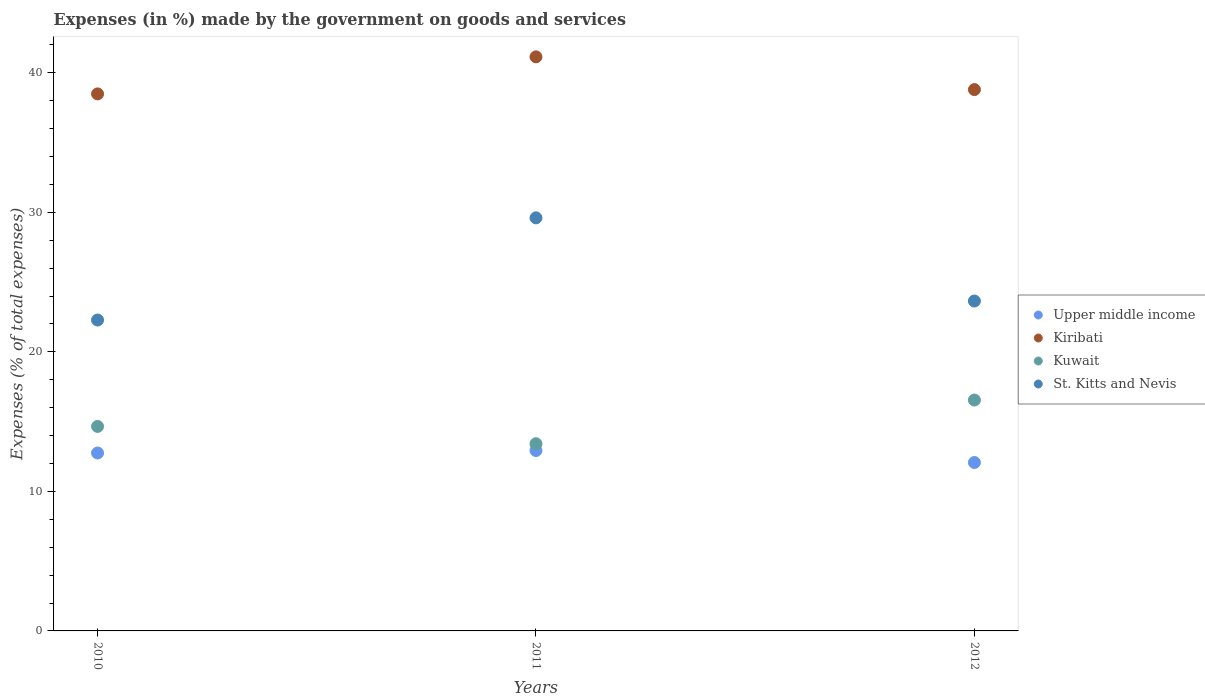How many different coloured dotlines are there?
Provide a short and direct response. 4. What is the percentage of expenses made by the government on goods and services in Kuwait in 2012?
Offer a very short reply. 16.55. Across all years, what is the maximum percentage of expenses made by the government on goods and services in Kuwait?
Offer a terse response. 16.55. Across all years, what is the minimum percentage of expenses made by the government on goods and services in Kuwait?
Make the answer very short. 13.41. In which year was the percentage of expenses made by the government on goods and services in Kuwait minimum?
Offer a very short reply. 2011. What is the total percentage of expenses made by the government on goods and services in Upper middle income in the graph?
Give a very brief answer. 37.75. What is the difference between the percentage of expenses made by the government on goods and services in Kiribati in 2011 and that in 2012?
Make the answer very short. 2.35. What is the difference between the percentage of expenses made by the government on goods and services in Upper middle income in 2011 and the percentage of expenses made by the government on goods and services in Kuwait in 2010?
Make the answer very short. -1.73. What is the average percentage of expenses made by the government on goods and services in Kuwait per year?
Give a very brief answer. 14.87. In the year 2012, what is the difference between the percentage of expenses made by the government on goods and services in Kiribati and percentage of expenses made by the government on goods and services in Upper middle income?
Offer a terse response. 26.72. What is the ratio of the percentage of expenses made by the government on goods and services in St. Kitts and Nevis in 2011 to that in 2012?
Your response must be concise. 1.25. What is the difference between the highest and the second highest percentage of expenses made by the government on goods and services in Kuwait?
Ensure brevity in your answer.  1.89. What is the difference between the highest and the lowest percentage of expenses made by the government on goods and services in Kiribati?
Your answer should be compact. 2.65. Is the sum of the percentage of expenses made by the government on goods and services in Kiribati in 2010 and 2011 greater than the maximum percentage of expenses made by the government on goods and services in St. Kitts and Nevis across all years?
Ensure brevity in your answer.  Yes. Is the percentage of expenses made by the government on goods and services in St. Kitts and Nevis strictly greater than the percentage of expenses made by the government on goods and services in Kiribati over the years?
Provide a succinct answer. No. How many dotlines are there?
Give a very brief answer. 4. How many years are there in the graph?
Your response must be concise. 3. What is the difference between two consecutive major ticks on the Y-axis?
Offer a terse response. 10. Are the values on the major ticks of Y-axis written in scientific E-notation?
Your response must be concise. No. Does the graph contain any zero values?
Your answer should be very brief. No. Where does the legend appear in the graph?
Provide a short and direct response. Center right. How many legend labels are there?
Your answer should be compact. 4. How are the legend labels stacked?
Give a very brief answer. Vertical. What is the title of the graph?
Your answer should be compact. Expenses (in %) made by the government on goods and services. What is the label or title of the X-axis?
Provide a succinct answer. Years. What is the label or title of the Y-axis?
Your answer should be very brief. Expenses (% of total expenses). What is the Expenses (% of total expenses) in Upper middle income in 2010?
Offer a terse response. 12.75. What is the Expenses (% of total expenses) in Kiribati in 2010?
Keep it short and to the point. 38.49. What is the Expenses (% of total expenses) of Kuwait in 2010?
Ensure brevity in your answer.  14.65. What is the Expenses (% of total expenses) in St. Kitts and Nevis in 2010?
Your answer should be compact. 22.28. What is the Expenses (% of total expenses) of Upper middle income in 2011?
Offer a terse response. 12.93. What is the Expenses (% of total expenses) of Kiribati in 2011?
Give a very brief answer. 41.14. What is the Expenses (% of total expenses) of Kuwait in 2011?
Keep it short and to the point. 13.41. What is the Expenses (% of total expenses) in St. Kitts and Nevis in 2011?
Your response must be concise. 29.6. What is the Expenses (% of total expenses) of Upper middle income in 2012?
Ensure brevity in your answer.  12.07. What is the Expenses (% of total expenses) of Kiribati in 2012?
Provide a succinct answer. 38.79. What is the Expenses (% of total expenses) in Kuwait in 2012?
Provide a short and direct response. 16.55. What is the Expenses (% of total expenses) of St. Kitts and Nevis in 2012?
Your answer should be compact. 23.64. Across all years, what is the maximum Expenses (% of total expenses) in Upper middle income?
Your answer should be very brief. 12.93. Across all years, what is the maximum Expenses (% of total expenses) in Kiribati?
Keep it short and to the point. 41.14. Across all years, what is the maximum Expenses (% of total expenses) of Kuwait?
Provide a short and direct response. 16.55. Across all years, what is the maximum Expenses (% of total expenses) of St. Kitts and Nevis?
Offer a very short reply. 29.6. Across all years, what is the minimum Expenses (% of total expenses) in Upper middle income?
Offer a very short reply. 12.07. Across all years, what is the minimum Expenses (% of total expenses) of Kiribati?
Offer a terse response. 38.49. Across all years, what is the minimum Expenses (% of total expenses) of Kuwait?
Your answer should be very brief. 13.41. Across all years, what is the minimum Expenses (% of total expenses) in St. Kitts and Nevis?
Provide a short and direct response. 22.28. What is the total Expenses (% of total expenses) of Upper middle income in the graph?
Provide a short and direct response. 37.75. What is the total Expenses (% of total expenses) in Kiribati in the graph?
Your answer should be compact. 118.42. What is the total Expenses (% of total expenses) of Kuwait in the graph?
Your answer should be compact. 44.61. What is the total Expenses (% of total expenses) in St. Kitts and Nevis in the graph?
Provide a succinct answer. 75.52. What is the difference between the Expenses (% of total expenses) of Upper middle income in 2010 and that in 2011?
Your answer should be compact. -0.18. What is the difference between the Expenses (% of total expenses) of Kiribati in 2010 and that in 2011?
Your response must be concise. -2.65. What is the difference between the Expenses (% of total expenses) in Kuwait in 2010 and that in 2011?
Your response must be concise. 1.24. What is the difference between the Expenses (% of total expenses) of St. Kitts and Nevis in 2010 and that in 2011?
Provide a succinct answer. -7.32. What is the difference between the Expenses (% of total expenses) in Upper middle income in 2010 and that in 2012?
Your answer should be very brief. 0.68. What is the difference between the Expenses (% of total expenses) of Kiribati in 2010 and that in 2012?
Your response must be concise. -0.31. What is the difference between the Expenses (% of total expenses) of Kuwait in 2010 and that in 2012?
Offer a very short reply. -1.89. What is the difference between the Expenses (% of total expenses) in St. Kitts and Nevis in 2010 and that in 2012?
Provide a succinct answer. -1.36. What is the difference between the Expenses (% of total expenses) of Upper middle income in 2011 and that in 2012?
Make the answer very short. 0.86. What is the difference between the Expenses (% of total expenses) of Kiribati in 2011 and that in 2012?
Ensure brevity in your answer.  2.35. What is the difference between the Expenses (% of total expenses) in Kuwait in 2011 and that in 2012?
Keep it short and to the point. -3.13. What is the difference between the Expenses (% of total expenses) of St. Kitts and Nevis in 2011 and that in 2012?
Your answer should be compact. 5.96. What is the difference between the Expenses (% of total expenses) in Upper middle income in 2010 and the Expenses (% of total expenses) in Kiribati in 2011?
Offer a very short reply. -28.39. What is the difference between the Expenses (% of total expenses) in Upper middle income in 2010 and the Expenses (% of total expenses) in Kuwait in 2011?
Ensure brevity in your answer.  -0.66. What is the difference between the Expenses (% of total expenses) of Upper middle income in 2010 and the Expenses (% of total expenses) of St. Kitts and Nevis in 2011?
Keep it short and to the point. -16.85. What is the difference between the Expenses (% of total expenses) in Kiribati in 2010 and the Expenses (% of total expenses) in Kuwait in 2011?
Offer a terse response. 25.07. What is the difference between the Expenses (% of total expenses) of Kiribati in 2010 and the Expenses (% of total expenses) of St. Kitts and Nevis in 2011?
Your answer should be very brief. 8.88. What is the difference between the Expenses (% of total expenses) of Kuwait in 2010 and the Expenses (% of total expenses) of St. Kitts and Nevis in 2011?
Give a very brief answer. -14.95. What is the difference between the Expenses (% of total expenses) in Upper middle income in 2010 and the Expenses (% of total expenses) in Kiribati in 2012?
Offer a terse response. -26.04. What is the difference between the Expenses (% of total expenses) in Upper middle income in 2010 and the Expenses (% of total expenses) in Kuwait in 2012?
Give a very brief answer. -3.79. What is the difference between the Expenses (% of total expenses) in Upper middle income in 2010 and the Expenses (% of total expenses) in St. Kitts and Nevis in 2012?
Make the answer very short. -10.89. What is the difference between the Expenses (% of total expenses) in Kiribati in 2010 and the Expenses (% of total expenses) in Kuwait in 2012?
Your response must be concise. 21.94. What is the difference between the Expenses (% of total expenses) in Kiribati in 2010 and the Expenses (% of total expenses) in St. Kitts and Nevis in 2012?
Your answer should be compact. 14.84. What is the difference between the Expenses (% of total expenses) of Kuwait in 2010 and the Expenses (% of total expenses) of St. Kitts and Nevis in 2012?
Provide a succinct answer. -8.99. What is the difference between the Expenses (% of total expenses) in Upper middle income in 2011 and the Expenses (% of total expenses) in Kiribati in 2012?
Provide a short and direct response. -25.86. What is the difference between the Expenses (% of total expenses) of Upper middle income in 2011 and the Expenses (% of total expenses) of Kuwait in 2012?
Provide a short and direct response. -3.62. What is the difference between the Expenses (% of total expenses) of Upper middle income in 2011 and the Expenses (% of total expenses) of St. Kitts and Nevis in 2012?
Ensure brevity in your answer.  -10.71. What is the difference between the Expenses (% of total expenses) of Kiribati in 2011 and the Expenses (% of total expenses) of Kuwait in 2012?
Your answer should be compact. 24.59. What is the difference between the Expenses (% of total expenses) of Kiribati in 2011 and the Expenses (% of total expenses) of St. Kitts and Nevis in 2012?
Give a very brief answer. 17.5. What is the difference between the Expenses (% of total expenses) in Kuwait in 2011 and the Expenses (% of total expenses) in St. Kitts and Nevis in 2012?
Offer a very short reply. -10.23. What is the average Expenses (% of total expenses) of Upper middle income per year?
Provide a succinct answer. 12.58. What is the average Expenses (% of total expenses) of Kiribati per year?
Give a very brief answer. 39.47. What is the average Expenses (% of total expenses) of Kuwait per year?
Ensure brevity in your answer.  14.87. What is the average Expenses (% of total expenses) of St. Kitts and Nevis per year?
Your answer should be very brief. 25.17. In the year 2010, what is the difference between the Expenses (% of total expenses) in Upper middle income and Expenses (% of total expenses) in Kiribati?
Offer a terse response. -25.73. In the year 2010, what is the difference between the Expenses (% of total expenses) of Upper middle income and Expenses (% of total expenses) of Kuwait?
Your answer should be very brief. -1.9. In the year 2010, what is the difference between the Expenses (% of total expenses) in Upper middle income and Expenses (% of total expenses) in St. Kitts and Nevis?
Provide a succinct answer. -9.53. In the year 2010, what is the difference between the Expenses (% of total expenses) of Kiribati and Expenses (% of total expenses) of Kuwait?
Your response must be concise. 23.83. In the year 2010, what is the difference between the Expenses (% of total expenses) in Kiribati and Expenses (% of total expenses) in St. Kitts and Nevis?
Your response must be concise. 16.21. In the year 2010, what is the difference between the Expenses (% of total expenses) of Kuwait and Expenses (% of total expenses) of St. Kitts and Nevis?
Ensure brevity in your answer.  -7.62. In the year 2011, what is the difference between the Expenses (% of total expenses) in Upper middle income and Expenses (% of total expenses) in Kiribati?
Offer a very short reply. -28.21. In the year 2011, what is the difference between the Expenses (% of total expenses) in Upper middle income and Expenses (% of total expenses) in Kuwait?
Your answer should be compact. -0.49. In the year 2011, what is the difference between the Expenses (% of total expenses) in Upper middle income and Expenses (% of total expenses) in St. Kitts and Nevis?
Your answer should be very brief. -16.67. In the year 2011, what is the difference between the Expenses (% of total expenses) in Kiribati and Expenses (% of total expenses) in Kuwait?
Keep it short and to the point. 27.73. In the year 2011, what is the difference between the Expenses (% of total expenses) in Kiribati and Expenses (% of total expenses) in St. Kitts and Nevis?
Provide a succinct answer. 11.54. In the year 2011, what is the difference between the Expenses (% of total expenses) of Kuwait and Expenses (% of total expenses) of St. Kitts and Nevis?
Keep it short and to the point. -16.19. In the year 2012, what is the difference between the Expenses (% of total expenses) in Upper middle income and Expenses (% of total expenses) in Kiribati?
Your response must be concise. -26.72. In the year 2012, what is the difference between the Expenses (% of total expenses) of Upper middle income and Expenses (% of total expenses) of Kuwait?
Provide a succinct answer. -4.48. In the year 2012, what is the difference between the Expenses (% of total expenses) of Upper middle income and Expenses (% of total expenses) of St. Kitts and Nevis?
Your answer should be very brief. -11.57. In the year 2012, what is the difference between the Expenses (% of total expenses) in Kiribati and Expenses (% of total expenses) in Kuwait?
Provide a succinct answer. 22.25. In the year 2012, what is the difference between the Expenses (% of total expenses) of Kiribati and Expenses (% of total expenses) of St. Kitts and Nevis?
Provide a short and direct response. 15.15. In the year 2012, what is the difference between the Expenses (% of total expenses) in Kuwait and Expenses (% of total expenses) in St. Kitts and Nevis?
Provide a short and direct response. -7.1. What is the ratio of the Expenses (% of total expenses) in Upper middle income in 2010 to that in 2011?
Your answer should be very brief. 0.99. What is the ratio of the Expenses (% of total expenses) in Kiribati in 2010 to that in 2011?
Your answer should be compact. 0.94. What is the ratio of the Expenses (% of total expenses) of Kuwait in 2010 to that in 2011?
Your answer should be very brief. 1.09. What is the ratio of the Expenses (% of total expenses) of St. Kitts and Nevis in 2010 to that in 2011?
Your answer should be compact. 0.75. What is the ratio of the Expenses (% of total expenses) of Upper middle income in 2010 to that in 2012?
Keep it short and to the point. 1.06. What is the ratio of the Expenses (% of total expenses) in Kuwait in 2010 to that in 2012?
Make the answer very short. 0.89. What is the ratio of the Expenses (% of total expenses) in St. Kitts and Nevis in 2010 to that in 2012?
Offer a very short reply. 0.94. What is the ratio of the Expenses (% of total expenses) of Upper middle income in 2011 to that in 2012?
Offer a terse response. 1.07. What is the ratio of the Expenses (% of total expenses) in Kiribati in 2011 to that in 2012?
Offer a terse response. 1.06. What is the ratio of the Expenses (% of total expenses) of Kuwait in 2011 to that in 2012?
Provide a short and direct response. 0.81. What is the ratio of the Expenses (% of total expenses) of St. Kitts and Nevis in 2011 to that in 2012?
Ensure brevity in your answer.  1.25. What is the difference between the highest and the second highest Expenses (% of total expenses) of Upper middle income?
Your response must be concise. 0.18. What is the difference between the highest and the second highest Expenses (% of total expenses) in Kiribati?
Your answer should be compact. 2.35. What is the difference between the highest and the second highest Expenses (% of total expenses) in Kuwait?
Offer a very short reply. 1.89. What is the difference between the highest and the second highest Expenses (% of total expenses) of St. Kitts and Nevis?
Give a very brief answer. 5.96. What is the difference between the highest and the lowest Expenses (% of total expenses) in Upper middle income?
Give a very brief answer. 0.86. What is the difference between the highest and the lowest Expenses (% of total expenses) of Kiribati?
Your response must be concise. 2.65. What is the difference between the highest and the lowest Expenses (% of total expenses) in Kuwait?
Ensure brevity in your answer.  3.13. What is the difference between the highest and the lowest Expenses (% of total expenses) in St. Kitts and Nevis?
Offer a very short reply. 7.32. 